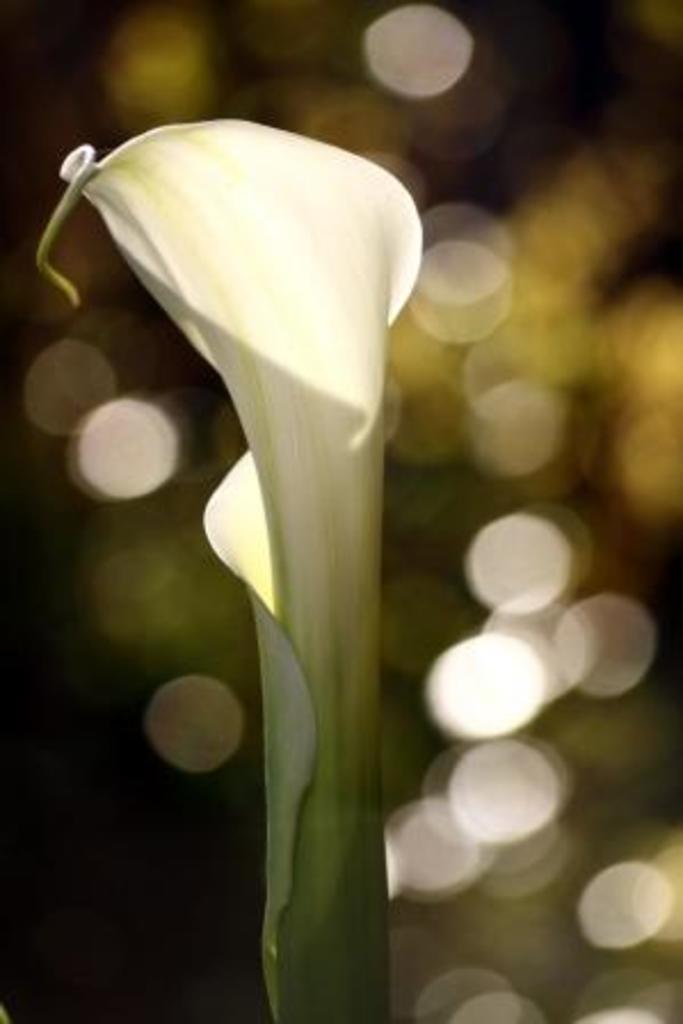In one or two sentences, can you explain what this image depicts? In this picture I can see petals in front, which are of white and green color. I see that it is totally blurred in the background. 